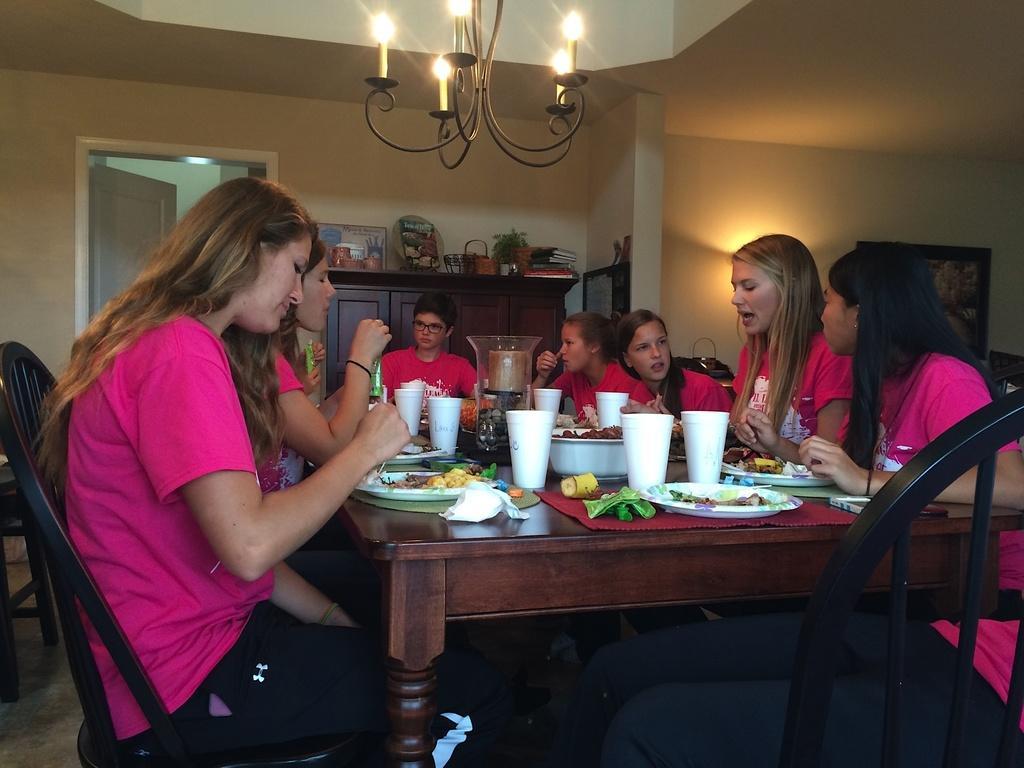Describe this image in one or two sentences. This picture is of inside. On the right we can see group of women wearing pink color t-shirts and sitting on the chairs. In the center there is a person wearing pink color t-shirt and sitting on the chair. On the left there are group of women also wearing pink color t-shirts and sitting on the chair and eating food. In the center we can see a table, on the top of which food items and glasses are placed. On the top we can see a candle stand hanging. In the background there is a picture frame hanging on the wall and a cabinet, on the top of which show pieces are placed and we can see a door. 